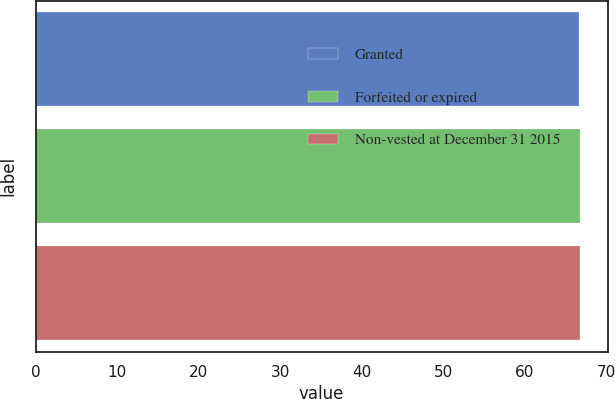Convert chart to OTSL. <chart><loc_0><loc_0><loc_500><loc_500><bar_chart><fcel>Granted<fcel>Forfeited or expired<fcel>Non-vested at December 31 2015<nl><fcel>66.63<fcel>66.73<fcel>66.83<nl></chart> 